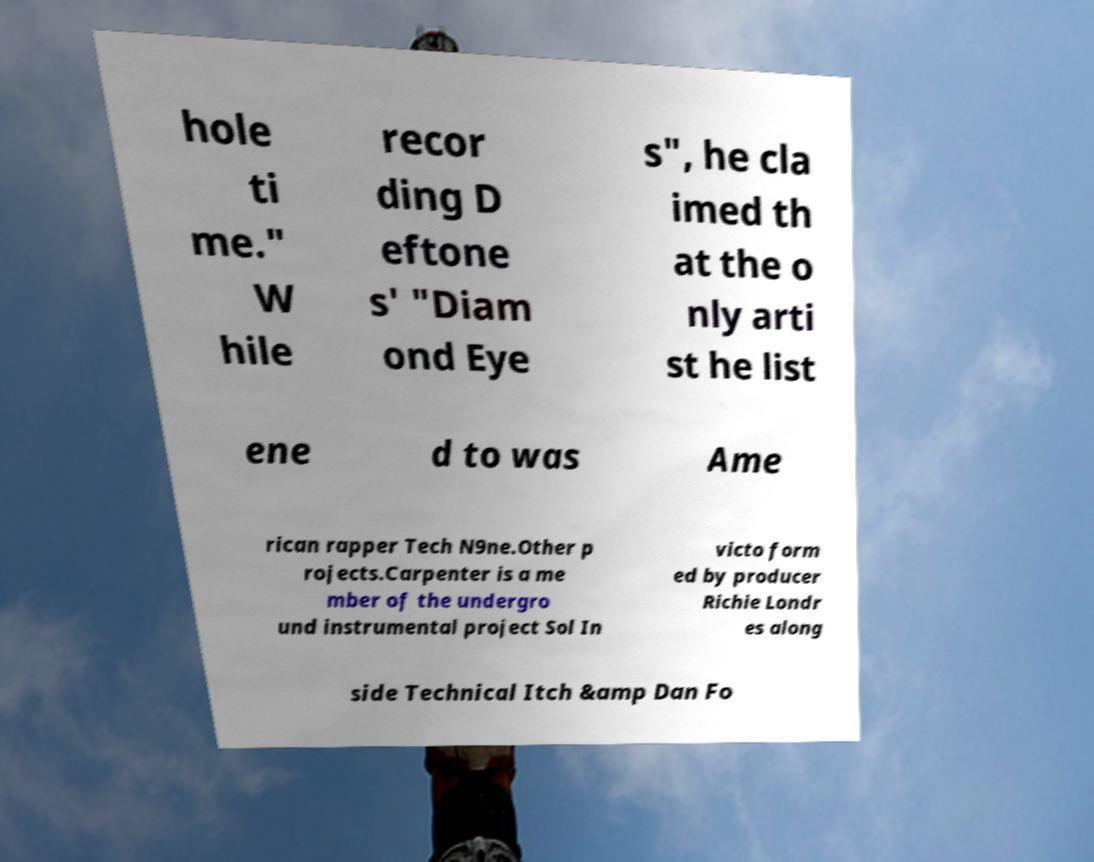Could you extract and type out the text from this image? hole ti me." W hile recor ding D eftone s' "Diam ond Eye s", he cla imed th at the o nly arti st he list ene d to was Ame rican rapper Tech N9ne.Other p rojects.Carpenter is a me mber of the undergro und instrumental project Sol In victo form ed by producer Richie Londr es along side Technical Itch &amp Dan Fo 